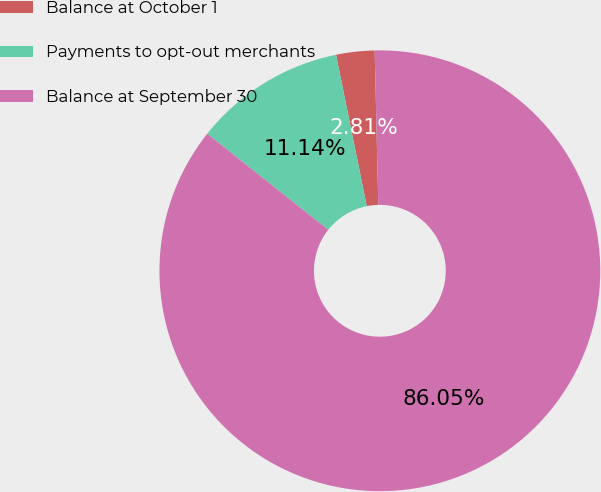Convert chart. <chart><loc_0><loc_0><loc_500><loc_500><pie_chart><fcel>Balance at October 1<fcel>Payments to opt-out merchants<fcel>Balance at September 30<nl><fcel>2.81%<fcel>11.14%<fcel>86.05%<nl></chart> 